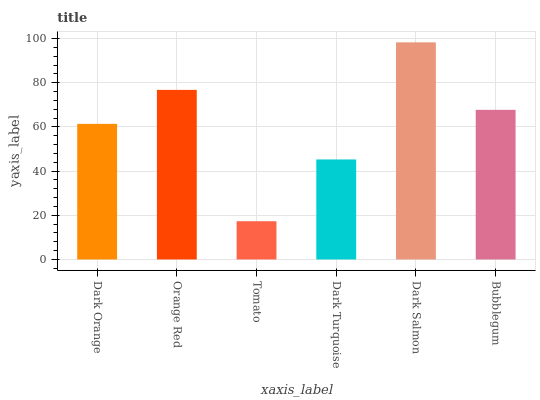Is Tomato the minimum?
Answer yes or no. Yes. Is Dark Salmon the maximum?
Answer yes or no. Yes. Is Orange Red the minimum?
Answer yes or no. No. Is Orange Red the maximum?
Answer yes or no. No. Is Orange Red greater than Dark Orange?
Answer yes or no. Yes. Is Dark Orange less than Orange Red?
Answer yes or no. Yes. Is Dark Orange greater than Orange Red?
Answer yes or no. No. Is Orange Red less than Dark Orange?
Answer yes or no. No. Is Bubblegum the high median?
Answer yes or no. Yes. Is Dark Orange the low median?
Answer yes or no. Yes. Is Tomato the high median?
Answer yes or no. No. Is Tomato the low median?
Answer yes or no. No. 